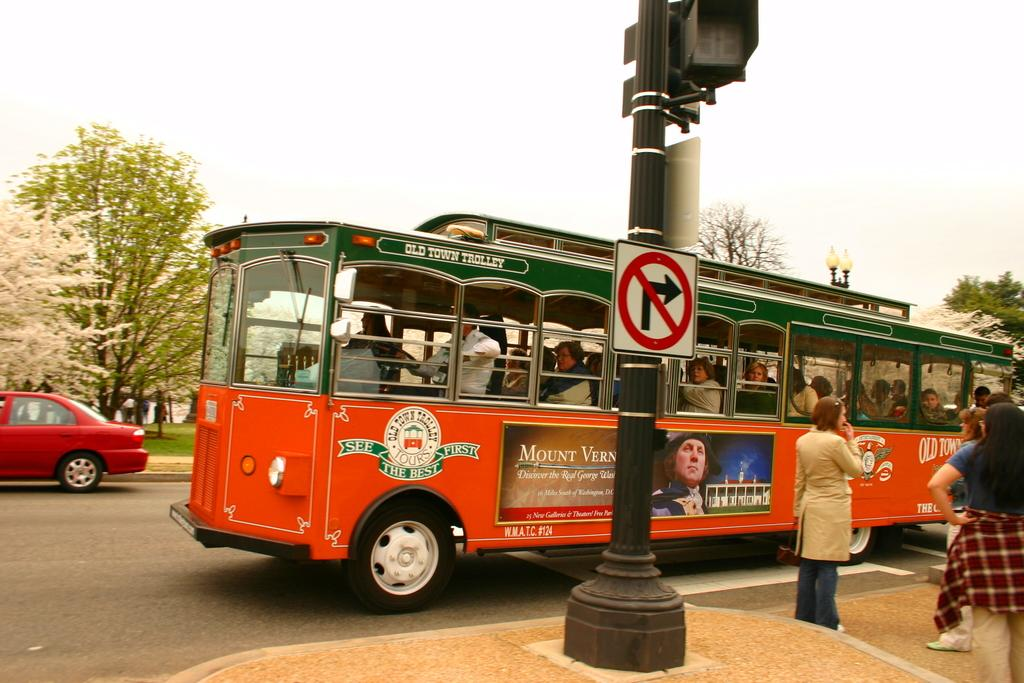What is the main subject of the image? The main subject of the image is a bus. What can be seen inside the bus? There are people sitting inside the bus. Where is the bus located? The bus is on the road. What is present near the bus? There is a pole in the image, and there are people standing near it. What can be seen in the background of the image? There are trees in the background of the image. How many eggs are being transported by the bus in the image? There is no indication of eggs being transported by the bus in the image. What type of station is depicted near the bus in the image? There is no station depicted in the image; it only shows a bus, a pole, and people standing near it. 